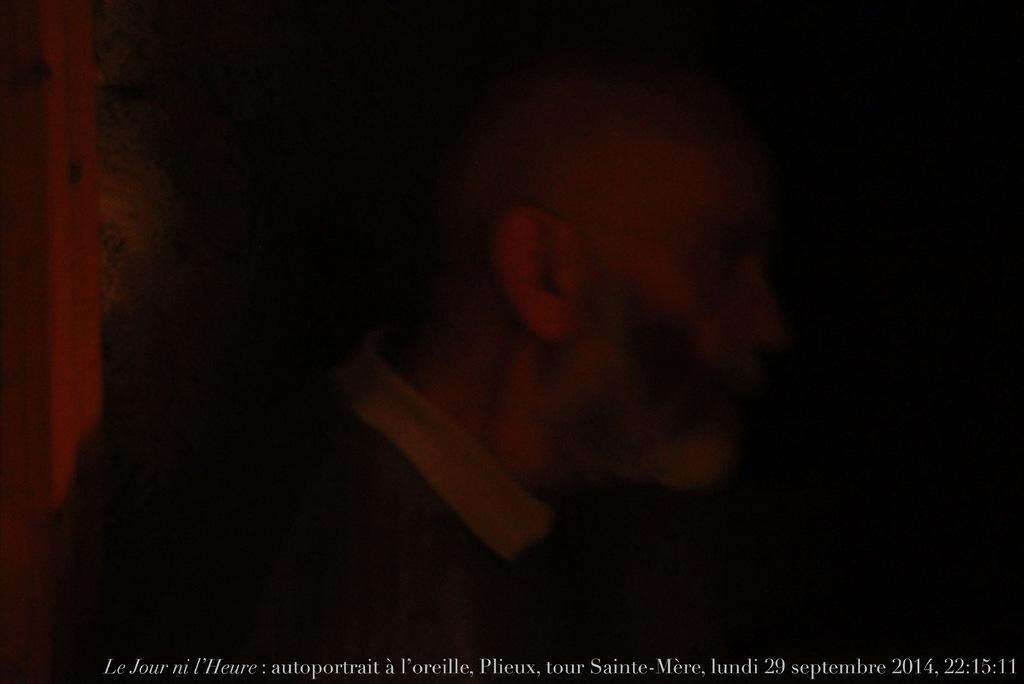How would you describe the lighting in the image? The image has less light. Can you tell me what is in the center of the image? There is a person in the center of the image. Where can you find additional information about the image? There is text, date, and time at the bottom of the image. How many frogs are jumping around the person in the image? There are no frogs present in the image. What type of flock is flying over the person in the image? There are no birds or flocks visible in the image. 